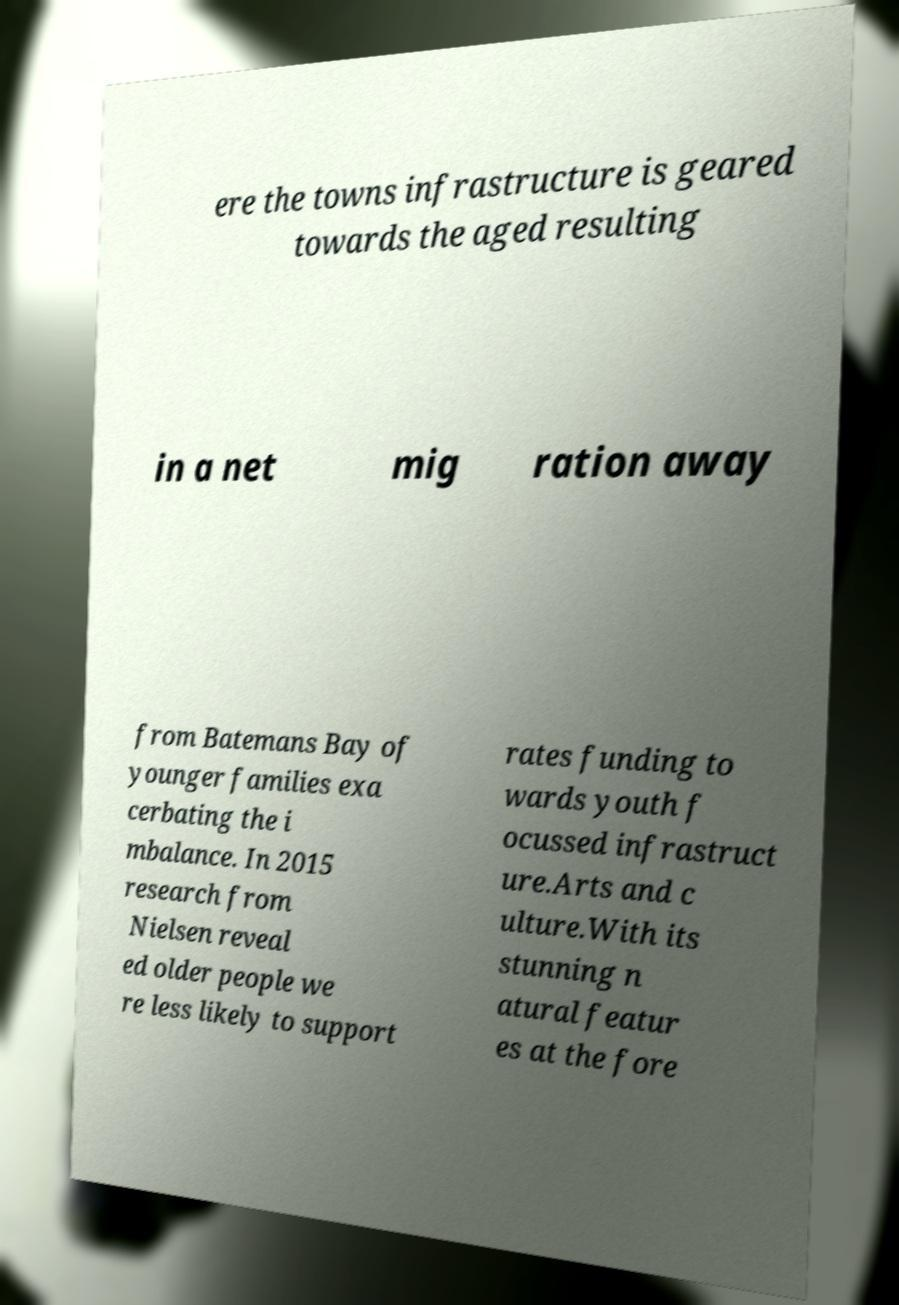Can you read and provide the text displayed in the image?This photo seems to have some interesting text. Can you extract and type it out for me? ere the towns infrastructure is geared towards the aged resulting in a net mig ration away from Batemans Bay of younger families exa cerbating the i mbalance. In 2015 research from Nielsen reveal ed older people we re less likely to support rates funding to wards youth f ocussed infrastruct ure.Arts and c ulture.With its stunning n atural featur es at the fore 